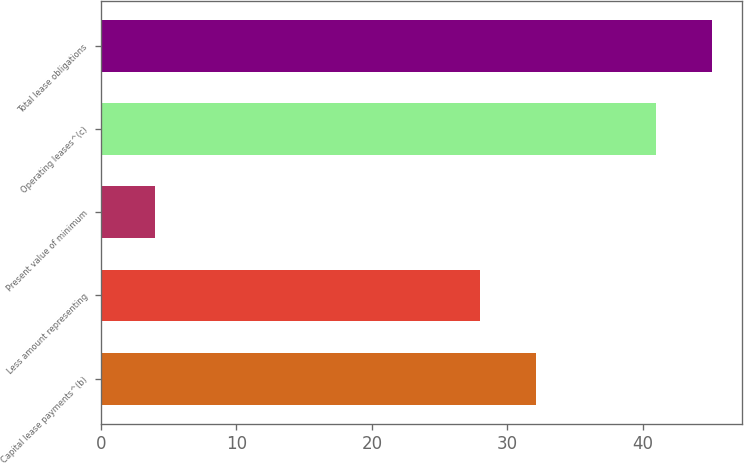<chart> <loc_0><loc_0><loc_500><loc_500><bar_chart><fcel>Capital lease payments^(b)<fcel>Less amount representing<fcel>Present value of minimum<fcel>Operating leases^(c)<fcel>Total lease obligations<nl><fcel>32.1<fcel>28<fcel>4<fcel>41<fcel>45.1<nl></chart> 